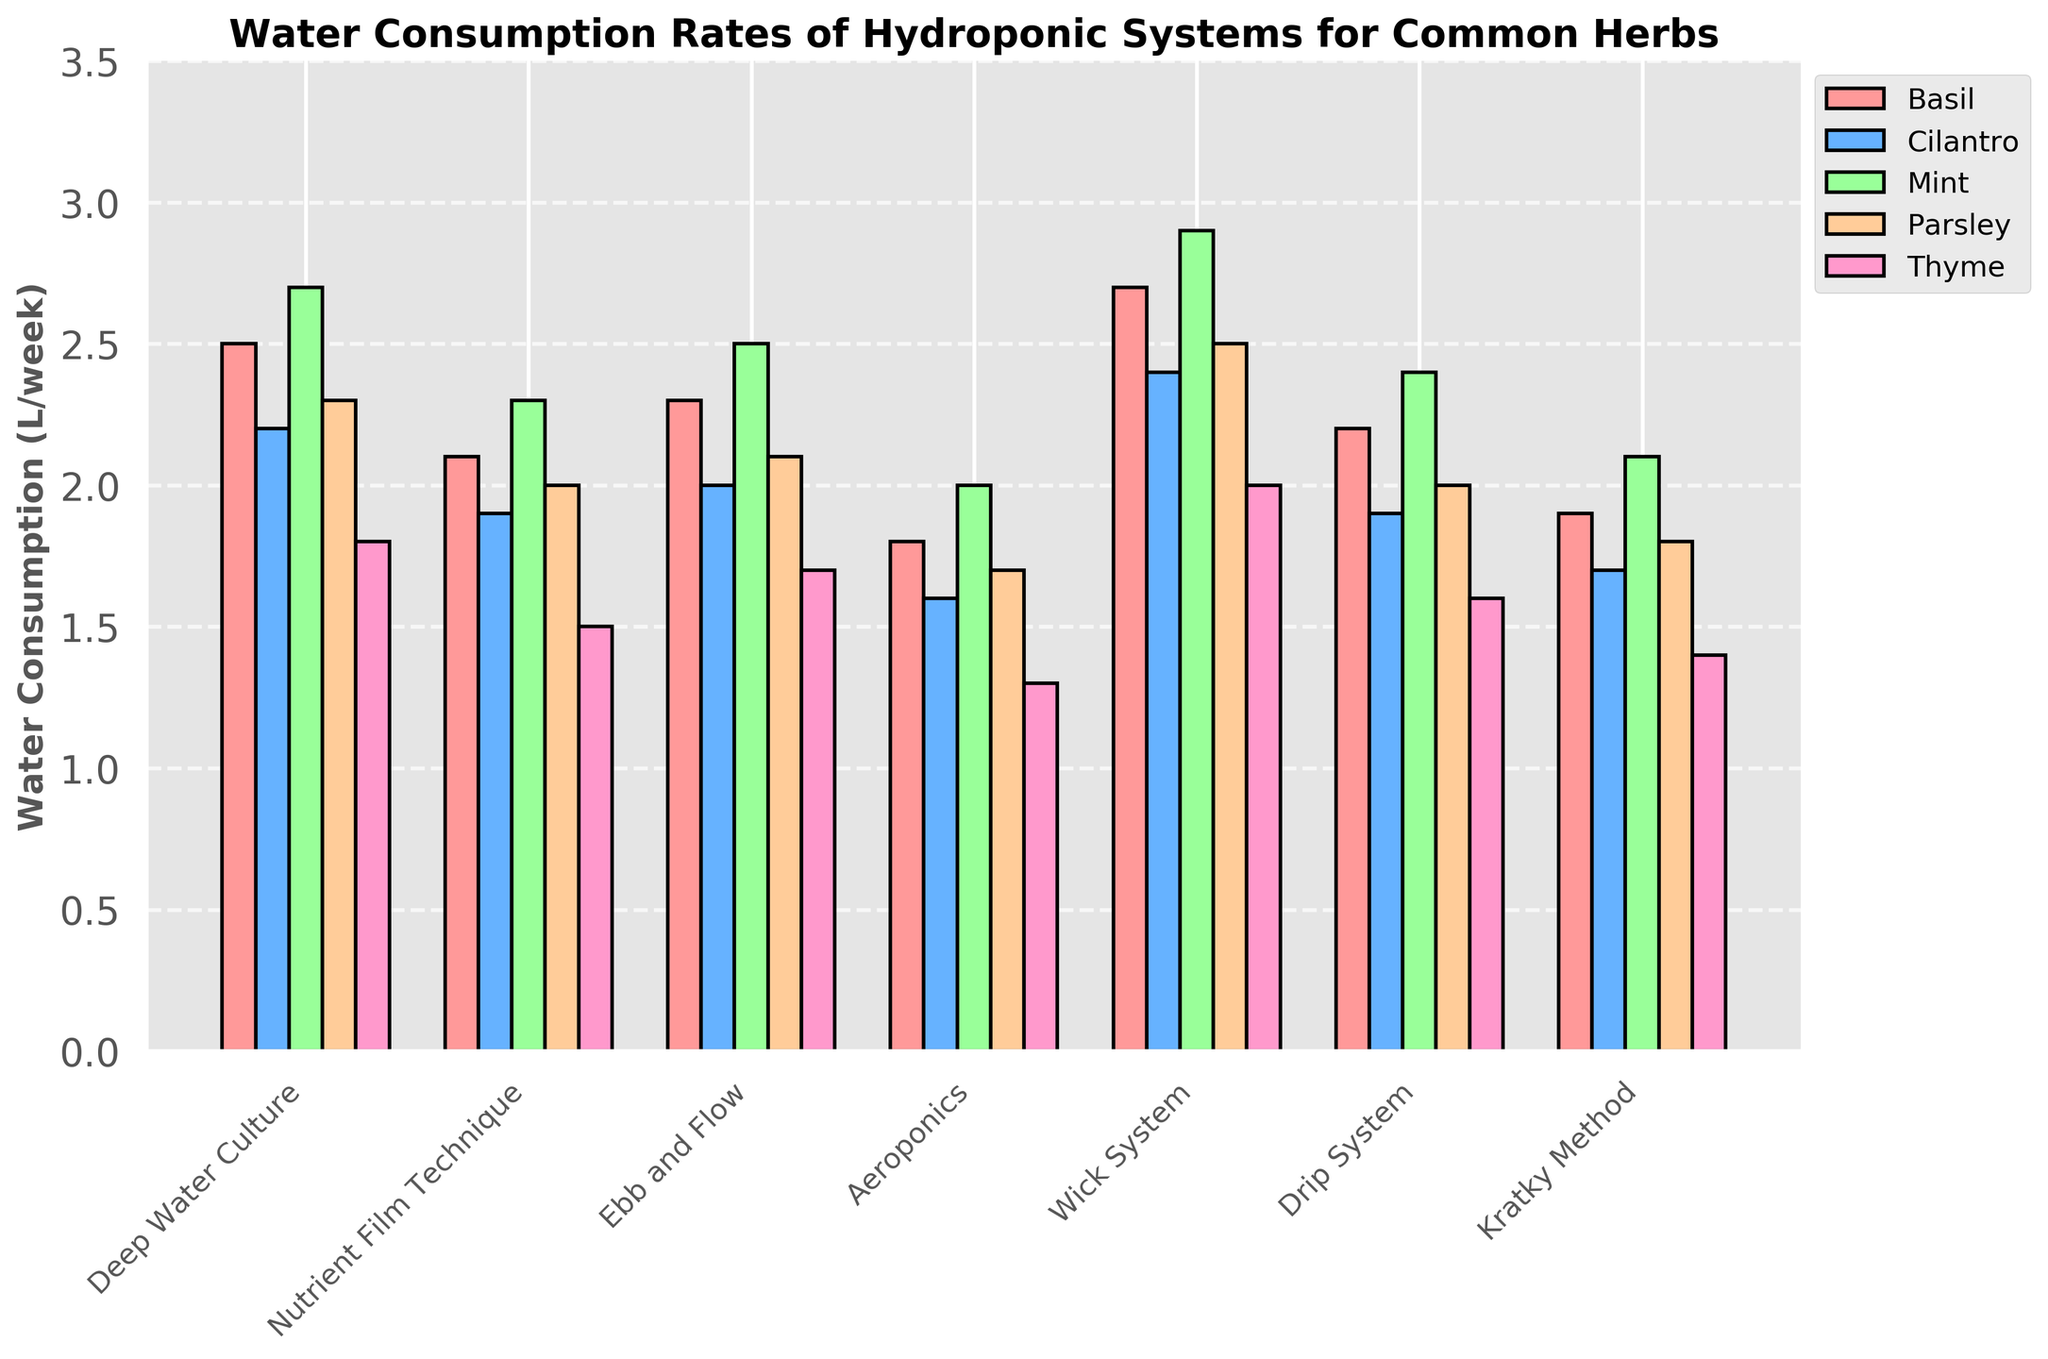Which hydroponic system has the highest water consumption for Basil? By visually inspecting the bar heights for Basil across all systems, the highest bar corresponds to the Wick System.
Answer: Wick System Which herb has the lowest average water consumption across all systems? To calculate the average water consumption for each herb, sum the consumption values of each herb across all systems and divide by 7. The resulting averages are: Basil=2.21, Cilantro=2.1, Mint=2.41, Parsley=2.06, and Thyme=1.61. Thyme has the lowest average consumption.
Answer: Thyme Is the water consumption for Mint in the Aeroponics system greater than in the Nutrient Film Technique system? By comparing the heights of the bars for Mint in Aeroponics and Nutrient Film Technique systems, we see that the bar for Nutrient Film Technique is higher. Therefore, the water consumption in Aeroponics is not greater.
Answer: No Which hydroponic system has the most consistent water consumption rates across all herbs? By examining the bar heights, we can see that the Ebb and Flow system has bars that are visually closest to each other in height across the different herbs compared to other systems.
Answer: Ebb and Flow What is the total water consumption for the Ebb and Flow system across all herbs? Sum the water consumption values for Ebb and Flow system: 2.3 (Basil) + 2.0 (Cilantro) + 2.5 (Mint) + 2.1 (Parsley) + 1.7 (Thyme) = 10.6 L/week.
Answer: 10.6 L/week How does the water consumption for Parsley in Deep Water Culture compare to that in the Kratky Method? By visually comparing the bar heights for Parsley, the bar for Deep Water Culture is higher than the bar for Kratky Method. Therefore, consumption is higher in Deep Water Culture.
Answer: Deep Water Culture has higher consumption Which herb has the highest difference in water consumption between the Wick System and Aeroponics? Calculate the difference in water consumption for each herb between Wick System and Aeroponics: Basil: 2.7 - 1.8 = 0.9, Cilantro: 2.4 - 1.6 = 0.8, Mint: 2.9 - 2.0 = 0.9, Parsley: 2.5 - 1.7 = 0.8, Thyme: 2.0 - 1.3 = 0.7. Basil and Mint both have the highest difference of 0.9 L/week.
Answer: Basil and Mint Which system has the lowest water consumption for Cilantro? By looking at the heights of the bars for Cilantro across all systems, the shortest bar corresponds to the Aeroponics system.
Answer: Aeroponics What is the range of water consumption for Thyme across all hydroponic systems? The range is found by subtracting the smallest value from the largest value for Thyme. The smallest is 1.3 L/week (Aeroponics), and the largest is 2.0 L/week (Wick System), so the range is 2.0 - 1.3 = 0.7.
Answer: 0.7 